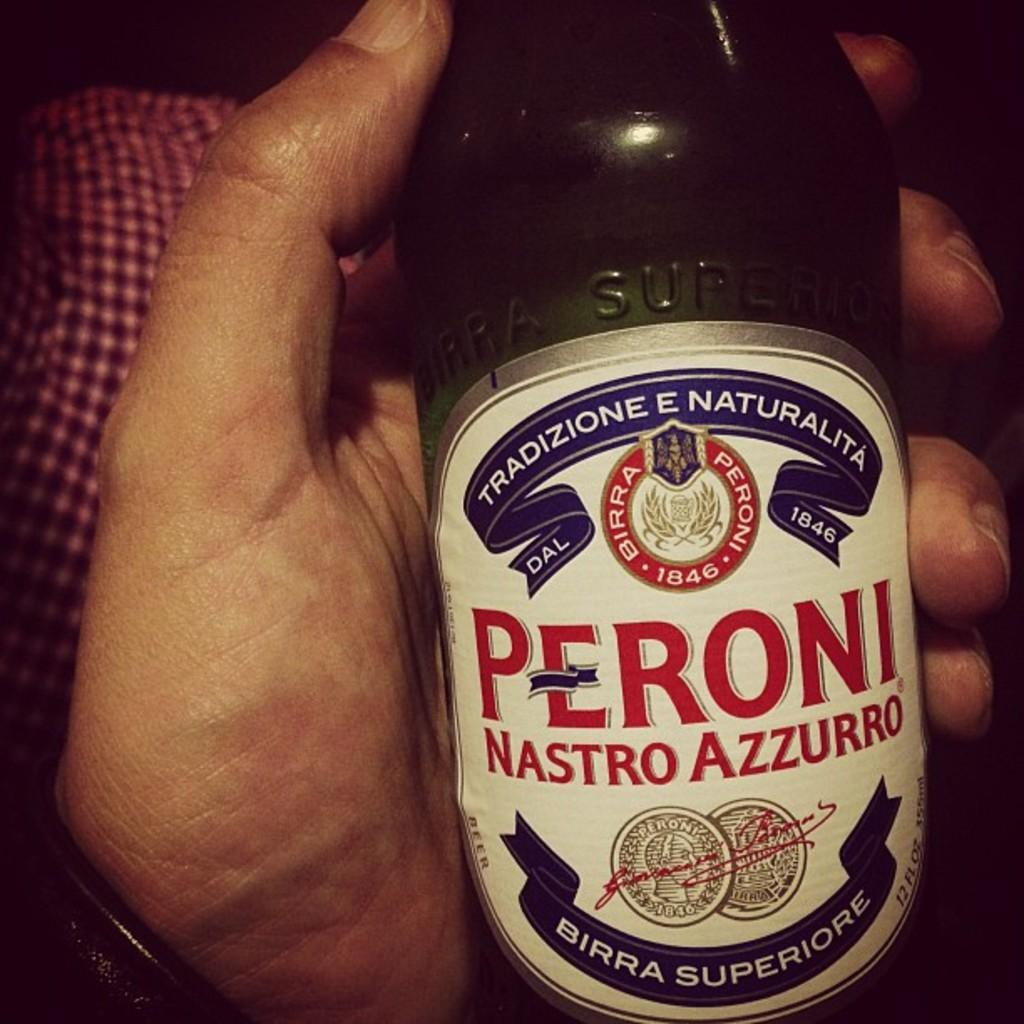Who or what is present in the image? There is a person in the image. What is the person holding in the image? The person is holding a bottle. Can you describe something in the background of the image? There is something red in the background of the image. What type of battle is taking place in the image? There is no battle present in the image; it features a person holding a bottle with something red in the background. Where is the desk located in the image? There is no desk present in the image. 